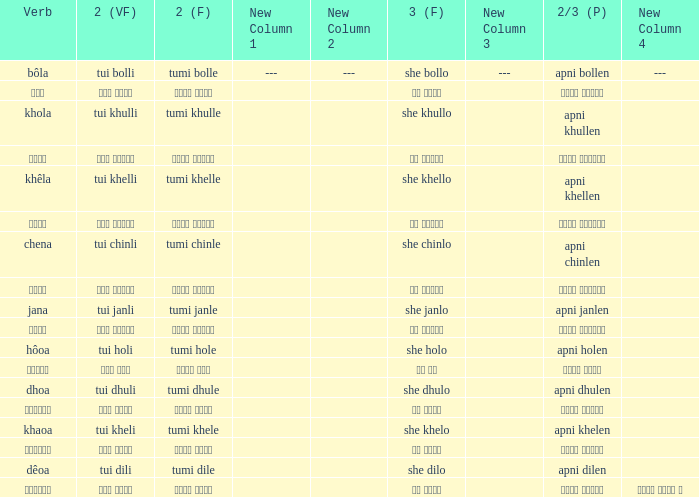What is the 2nd verb for chena? Tumi chinle. 